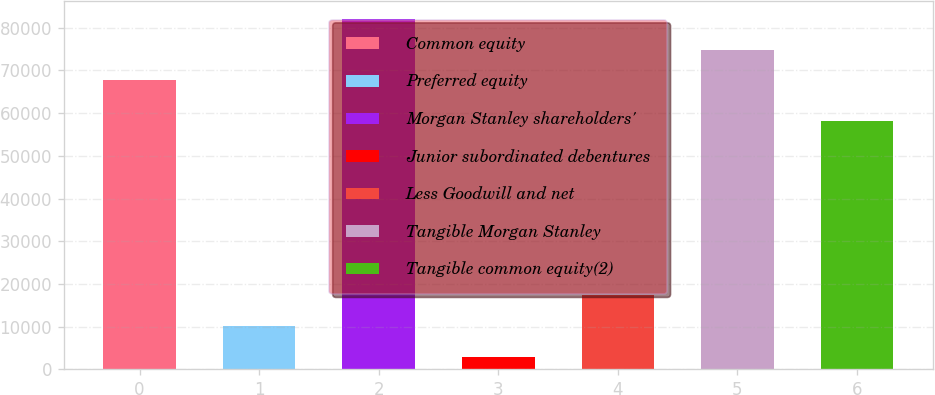<chart> <loc_0><loc_0><loc_500><loc_500><bar_chart><fcel>Common equity<fcel>Preferred equity<fcel>Morgan Stanley shareholders'<fcel>Junior subordinated debentures<fcel>Less Goodwill and net<fcel>Tangible Morgan Stanley<fcel>Tangible common equity(2)<nl><fcel>67662<fcel>10101.2<fcel>82124.4<fcel>2870<fcel>17332.4<fcel>74893.2<fcel>58098<nl></chart> 